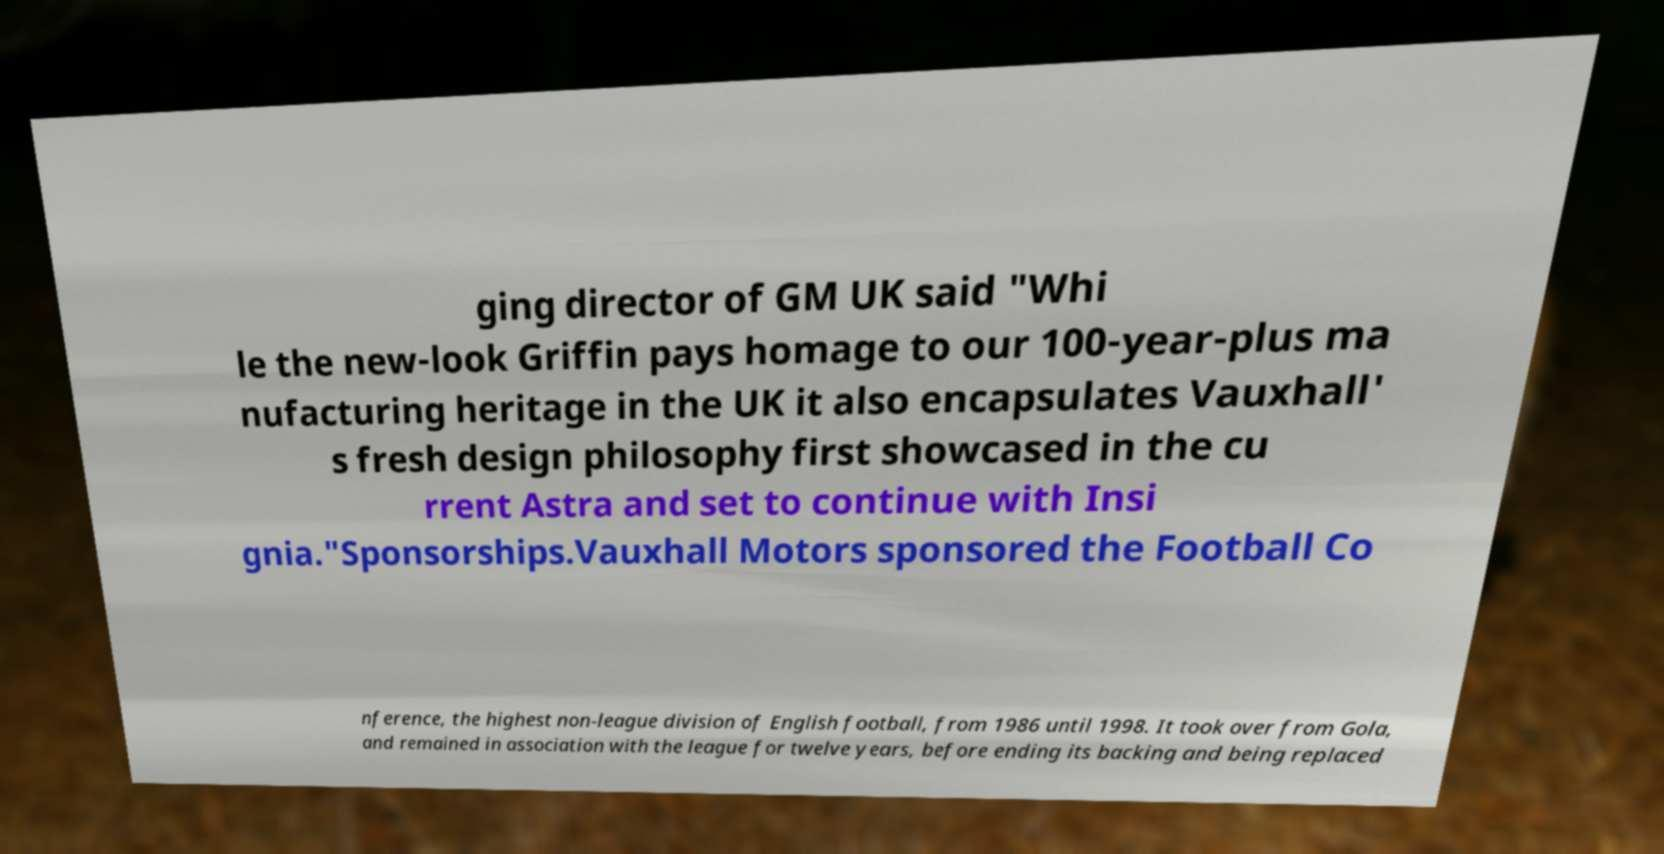For documentation purposes, I need the text within this image transcribed. Could you provide that? ging director of GM UK said "Whi le the new-look Griffin pays homage to our 100-year-plus ma nufacturing heritage in the UK it also encapsulates Vauxhall' s fresh design philosophy first showcased in the cu rrent Astra and set to continue with Insi gnia."Sponsorships.Vauxhall Motors sponsored the Football Co nference, the highest non-league division of English football, from 1986 until 1998. It took over from Gola, and remained in association with the league for twelve years, before ending its backing and being replaced 